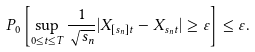<formula> <loc_0><loc_0><loc_500><loc_500>P _ { 0 } \left [ \sup _ { 0 \leq t \leq T } \frac { 1 } { \sqrt { s _ { n } } } | X _ { [ s _ { n } ] t } - X _ { s _ { n } t } | \geq \varepsilon \right ] \leq \varepsilon .</formula> 